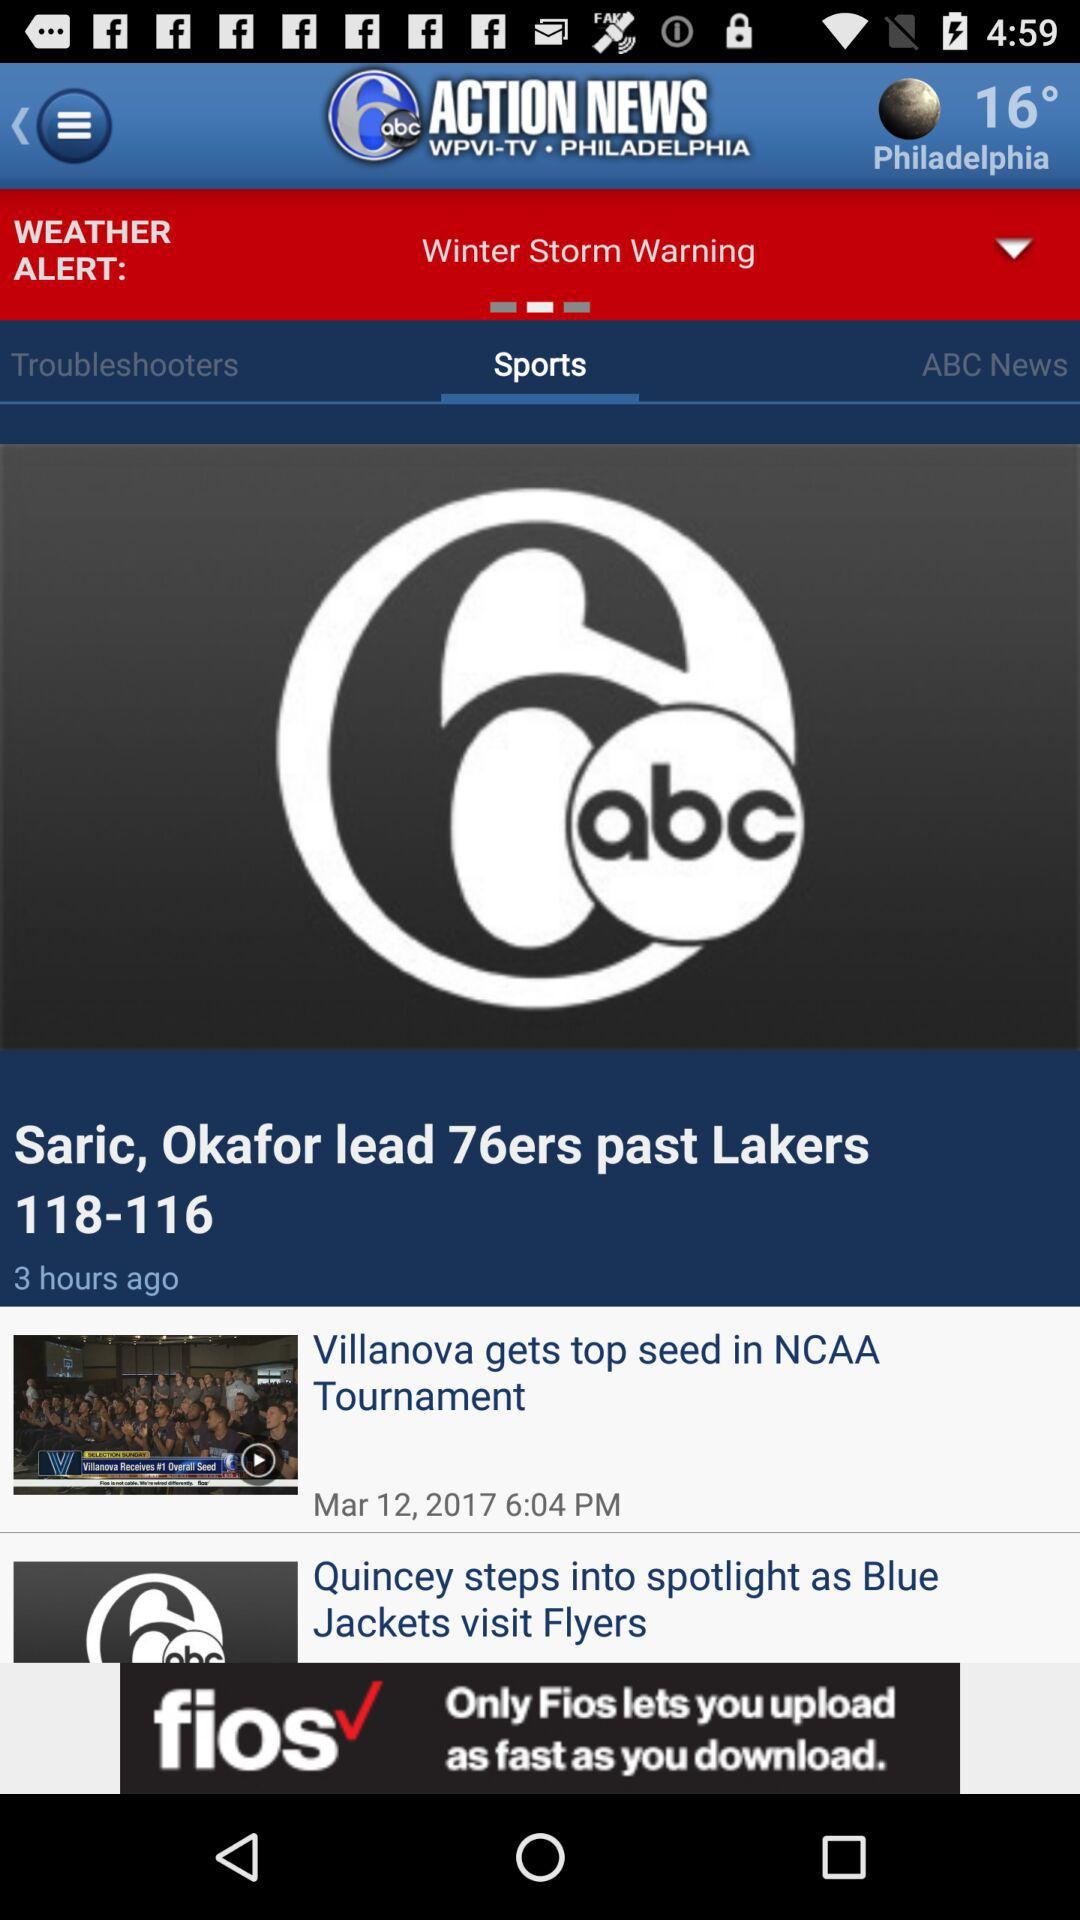What is the time and date of "Villanova gets top seed in NCAA Tournament"? The time and date of "Villanova gets top seed in NCAA Tournament" are 6:04 p.m. and March 12, 2017, respectively. 